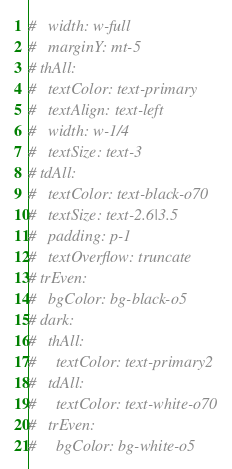Convert code to text. <code><loc_0><loc_0><loc_500><loc_500><_YAML_>#   width: w-full
#   marginY: mt-5
# thAll:
#   textColor: text-primary
#   textAlign: text-left
#   width: w-1/4
#   textSize: text-3
# tdAll:
#   textColor: text-black-o70
#   textSize: text-2.6|3.5
#   padding: p-1
#   textOverflow: truncate
# trEven:
#   bgColor: bg-black-o5
# dark:
#   thAll:
#     textColor: text-primary2
#   tdAll:
#     textColor: text-white-o70
#   trEven:
#     bgColor: bg-white-o5</code> 